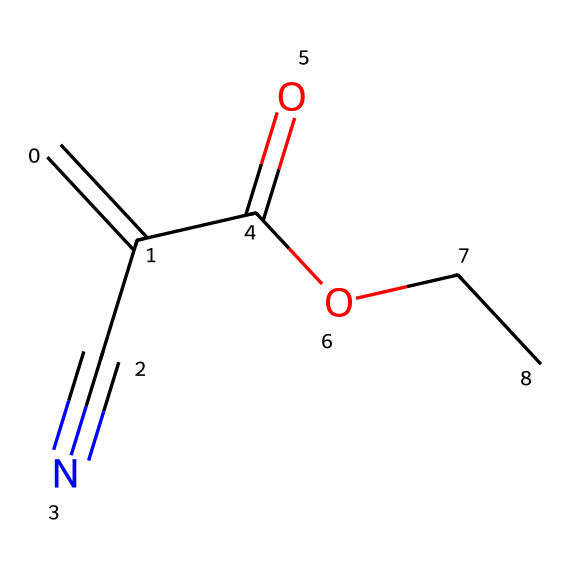What is the functional group present in this molecule? The structure contains a carboxylic acid group (-COOH), indicated by the presence of the carbonyl (C=O) linked to a hydroxyl group (OH).
Answer: carboxylic acid How many carbon atoms are in the molecule? By analyzing the structure, we can count five carbon atoms represented in the chain and functional groups.
Answer: five What type of bond connects the carbon atoms in the chain? The carbon atoms in the chain are connected by single bonds (C-C), while there is also a double bond (C=C) between two carbon atoms.
Answer: single and double bonds Does this chemical have any nitrogen atoms? Upon examining the structure, we can see one nitrogen atom (from the cyano group -C#N) present, indicating its presence.
Answer: yes What type of compound is this molecule classified as? This molecule is classified as a non-electrolyte due to its structure lacking the ability to dissociate into ions in solution, retaining covalent bonds.
Answer: non-electrolyte What effect does the presence of the carboxylic acid group have on the solubility of this compound? The carboxylic acid group increases the polarity of the molecule, allowing it to dissolve in polar solvents while remaining a non-electrolyte.
Answer: increases solubility 